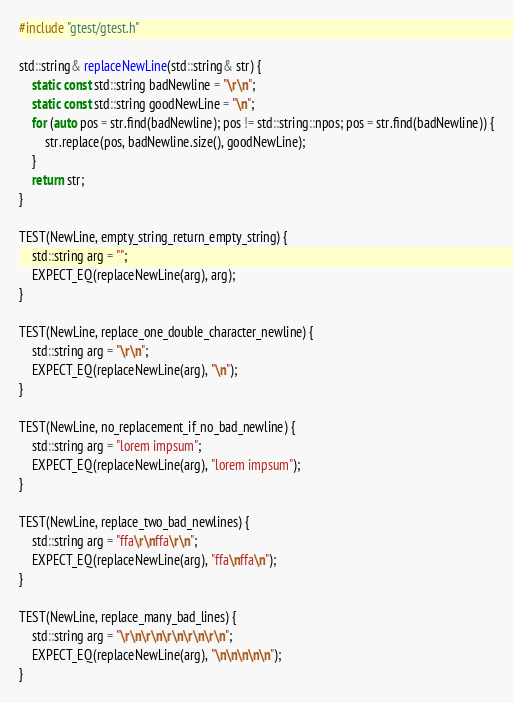Convert code to text. <code><loc_0><loc_0><loc_500><loc_500><_C++_>#include "gtest/gtest.h"

std::string& replaceNewLine(std::string& str) {
    static const std::string badNewline = "\r\n";
    static const std::string goodNewLine = "\n";
    for (auto pos = str.find(badNewline); pos != std::string::npos; pos = str.find(badNewline)) {
        str.replace(pos, badNewline.size(), goodNewLine);
    }
    return str;
}

TEST(NewLine, empty_string_return_empty_string) {
    std::string arg = "";
    EXPECT_EQ(replaceNewLine(arg), arg);
}

TEST(NewLine, replace_one_double_character_newline) {
    std::string arg = "\r\n";
    EXPECT_EQ(replaceNewLine(arg), "\n");
}

TEST(NewLine, no_replacement_if_no_bad_newline) {
    std::string arg = "lorem impsum";
    EXPECT_EQ(replaceNewLine(arg), "lorem impsum");
}

TEST(NewLine, replace_two_bad_newlines) {
    std::string arg = "ffa\r\nffa\r\n";
    EXPECT_EQ(replaceNewLine(arg), "ffa\nffa\n");
}

TEST(NewLine, replace_many_bad_lines) {
    std::string arg = "\r\n\r\n\r\n\r\n\r\n";
    EXPECT_EQ(replaceNewLine(arg), "\n\n\n\n\n");
}
</code> 